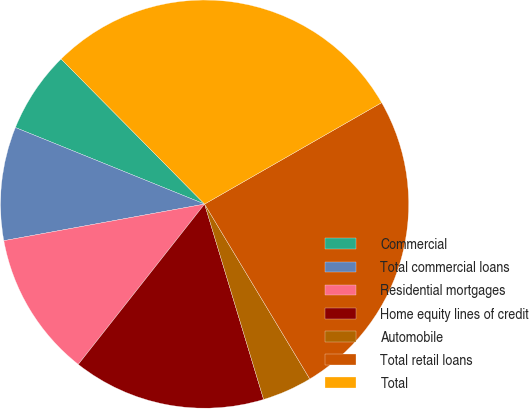<chart> <loc_0><loc_0><loc_500><loc_500><pie_chart><fcel>Commercial<fcel>Total commercial loans<fcel>Residential mortgages<fcel>Home equity lines of credit<fcel>Automobile<fcel>Total retail loans<fcel>Total<nl><fcel>6.47%<fcel>8.99%<fcel>11.51%<fcel>15.29%<fcel>3.95%<fcel>24.66%<fcel>29.13%<nl></chart> 